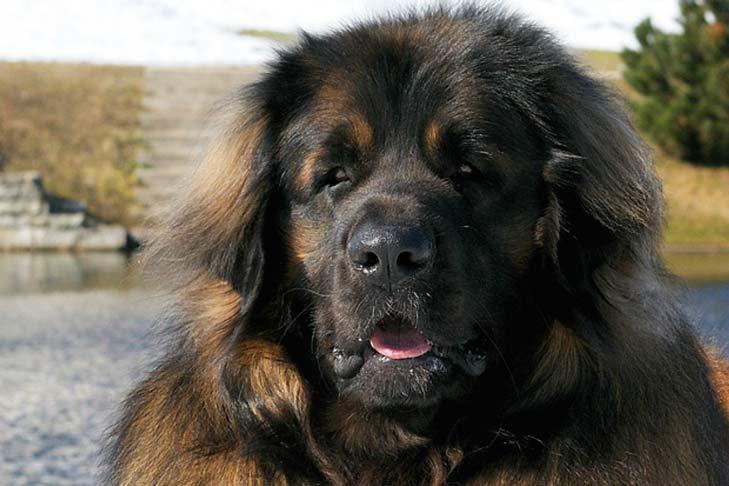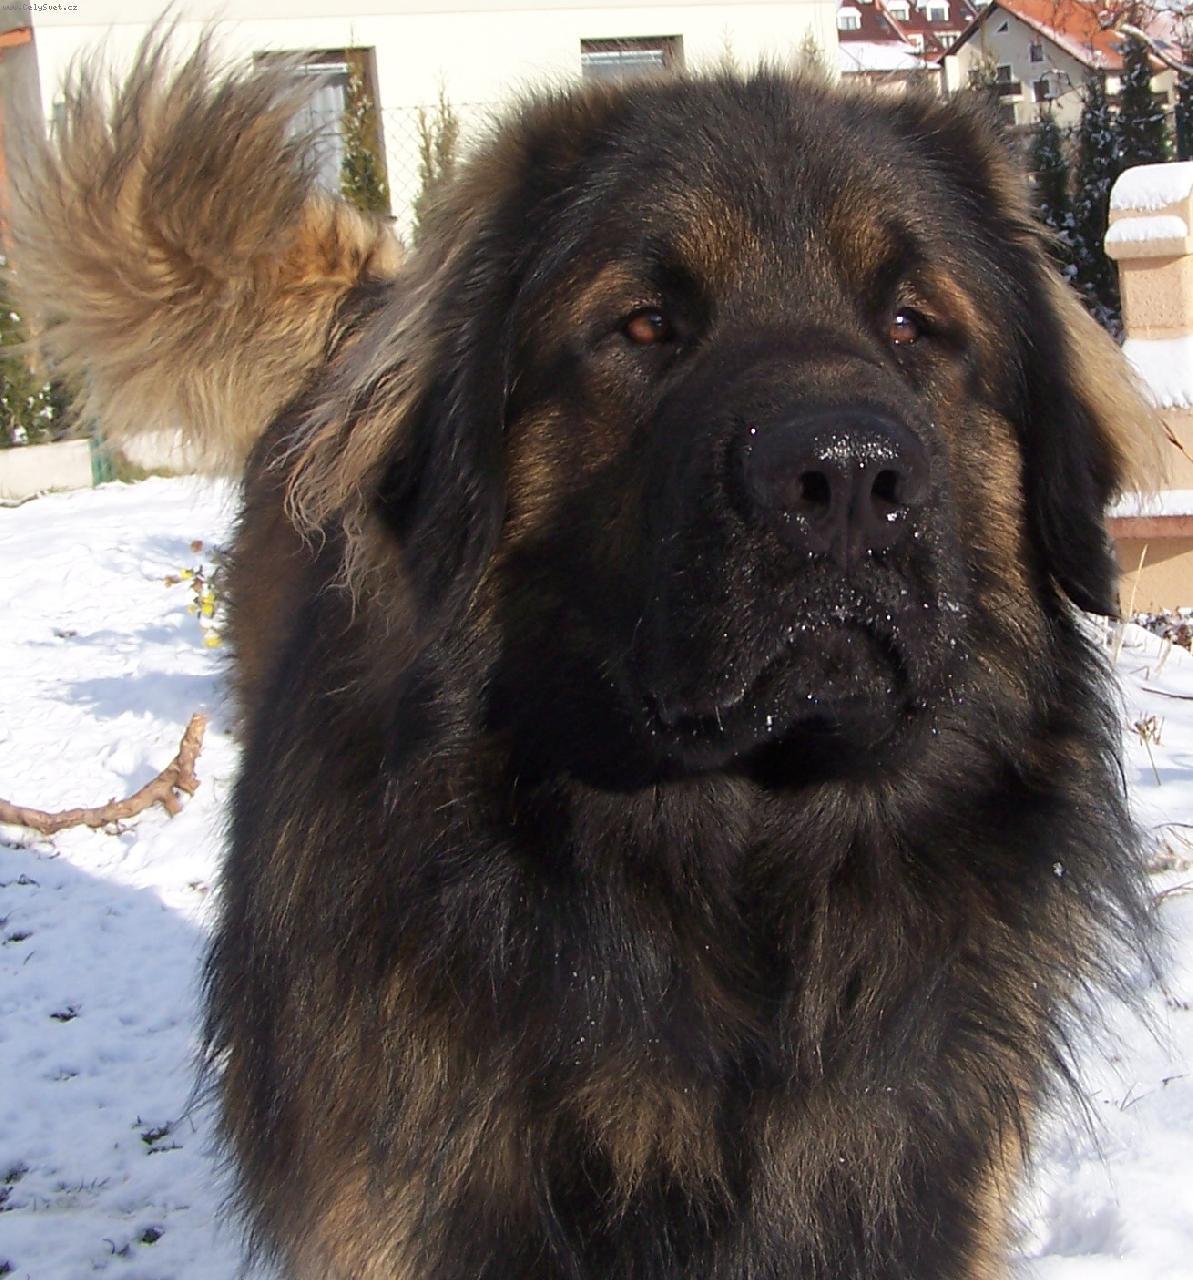The first image is the image on the left, the second image is the image on the right. Considering the images on both sides, is "There is more than one dog in one of the images." valid? Answer yes or no. No. 